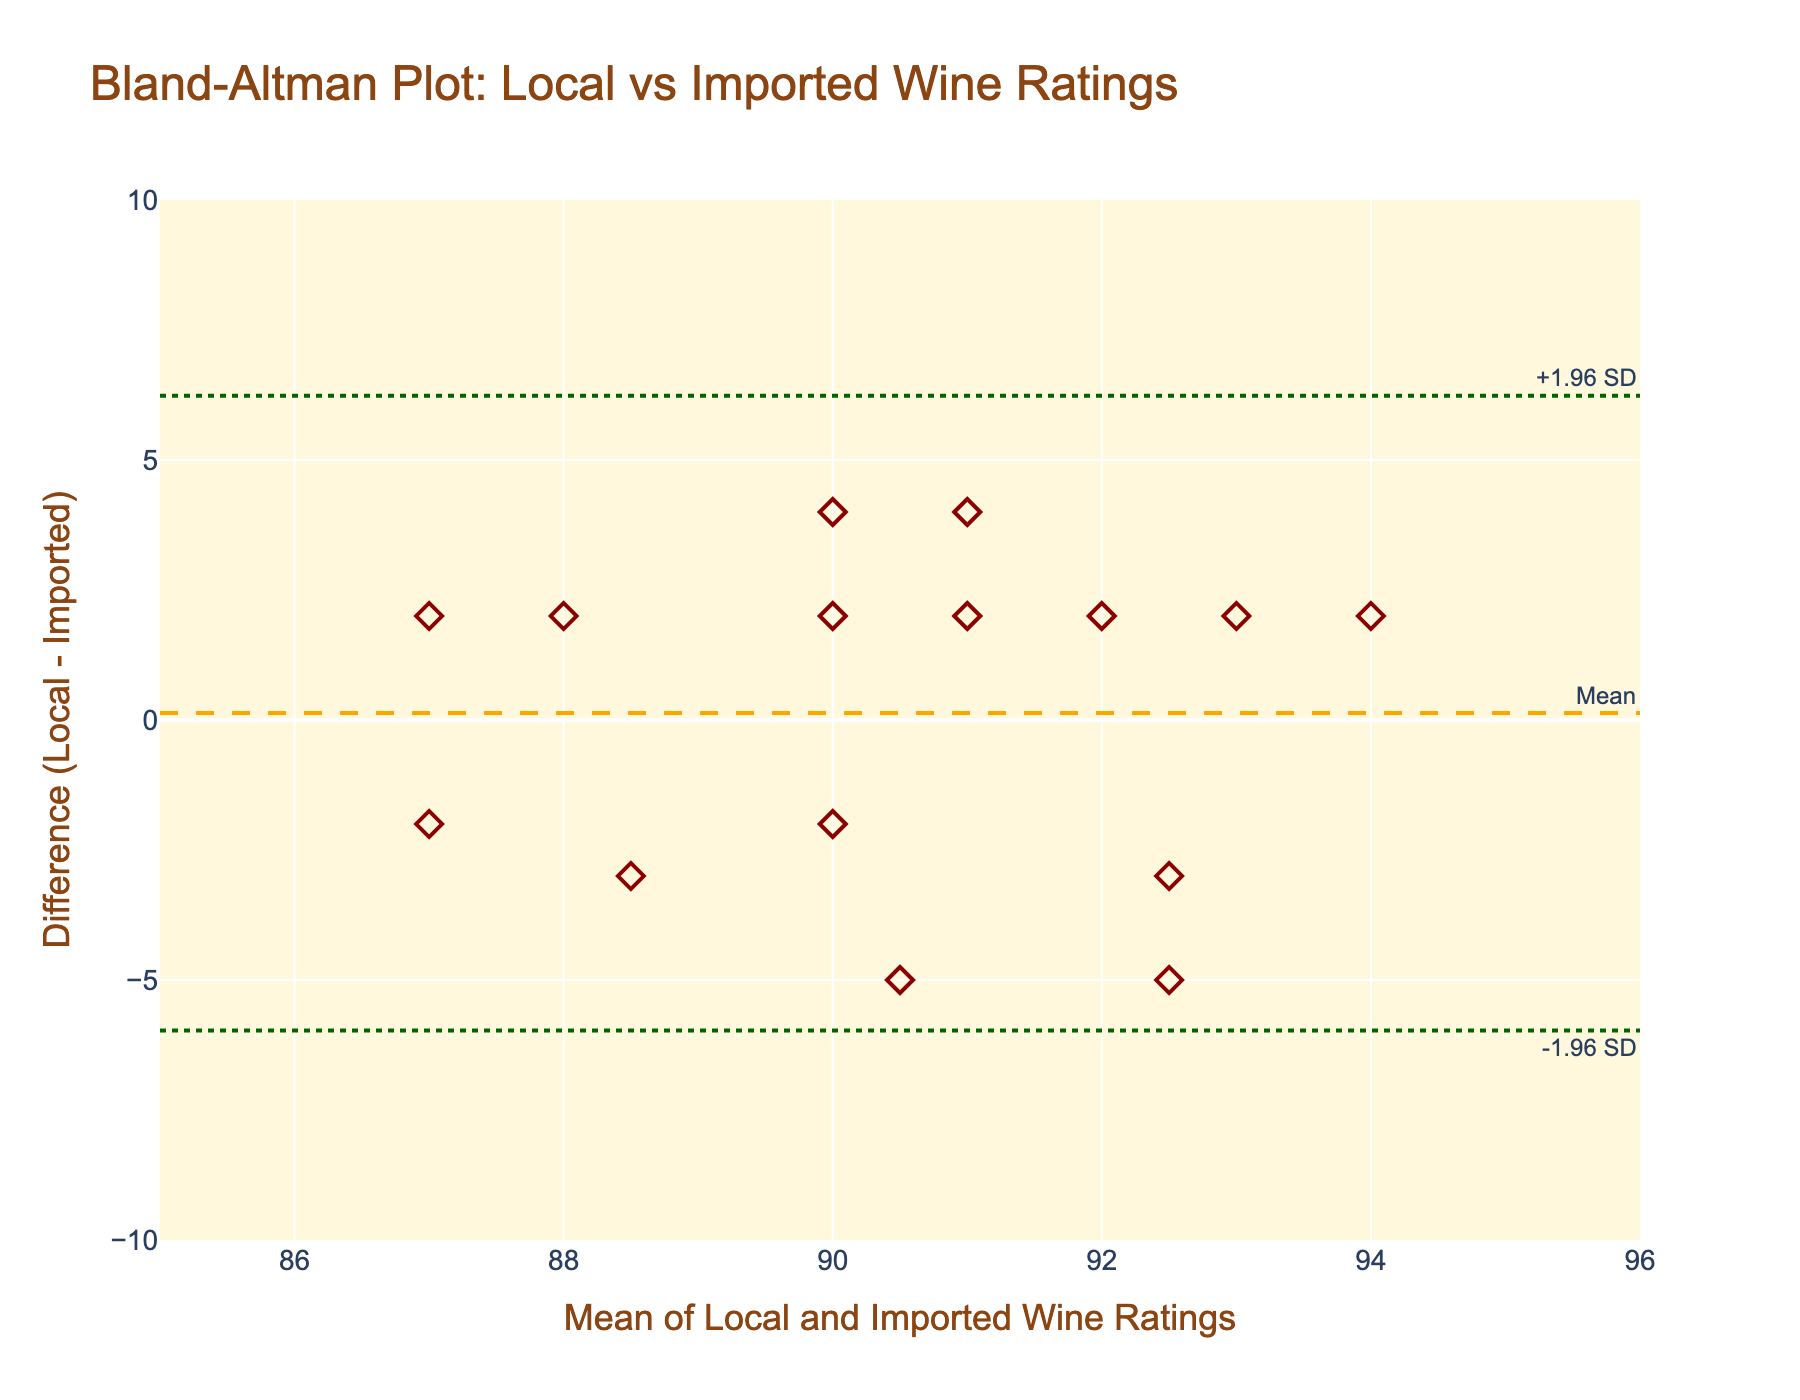What's the title of the plot? The title of the figure is usually positioned at the top of the plot. The title in this figure reads "Bland-Altman Plot: Local vs Imported Wine Ratings."
Answer: Bland-Altman Plot: Local vs Imported Wine Ratings What do the x-axis and y-axis represent? Looking at the axes' titles, the x-axis represents the "Mean of Local and Imported Wine Ratings," and the y-axis represents the "Difference (Local - Imported) Ratings."
Answer: The x-axis represents the Mean of Local and Imported Wine Ratings, and the y-axis represents the Difference (Local - Imported) Ratings How many points are plotted in the figure? Each wine taster's rating pair corresponds to one data point on the plot. Counting the wine tasters, there are 15 data points plotted in the figure.
Answer: 15 What's the mean difference in wine ratings between local and imported wines? The mean difference is indicated by a horizontal dashed line with the annotation "Mean," located at the mean difference value on the y-axis.
Answer: 0.0667 What are the limits of agreement for the differences in ratings? The limits of agreement are indicated by two horizontal dotted lines labeled "-1.96 SD" and "+1.96 SD."
Answer: The lower limit is -4.45, and the upper limit is 4.58 What's the average rating difference for Miguel Ruiz? For Miguel Ruiz, the Local Wine Rating is 92, and the Imported Wine Rating is 88. The difference is calculated by subtracting the Imported rating from the Local rating, which is 92 - 88.
Answer: 4 Which expert gave the most differing ratings between local and imported wines? By comparing the difference values, the expert with the highest positive or negative value indicates the most differing ratings. Alejandro García gave the most differing ratings with 88 for Local and 93 for Imported, resulting in a difference of -5.
Answer: Alejandro García Are any data points outside the limits of agreement? By checking if any points lie beyond the limits of agreement, you can see whether they fall inside or outside those horizontal lines. No data points lie outside the given limits of -4.45 and 4.58.
Answer: No Which expert's ratings are closest to zero on the difference scale? The closest to zero would be the point nearest to the y-axis origin (difference of 0). Elena Rodríguez has the ratings of Local 94 and Imported 92, giving a difference of 2, which is the closest positive value.
Answer: Elena Rodríguez What is the range of the mean of Local and Imported Wine Ratings? To find the range, identify the minimum and maximum values on the x-axis. The plotted points appear to range between 86 and 94 on the Mean of Local and Imported Wine Ratings axis.
Answer: 86 to 94 